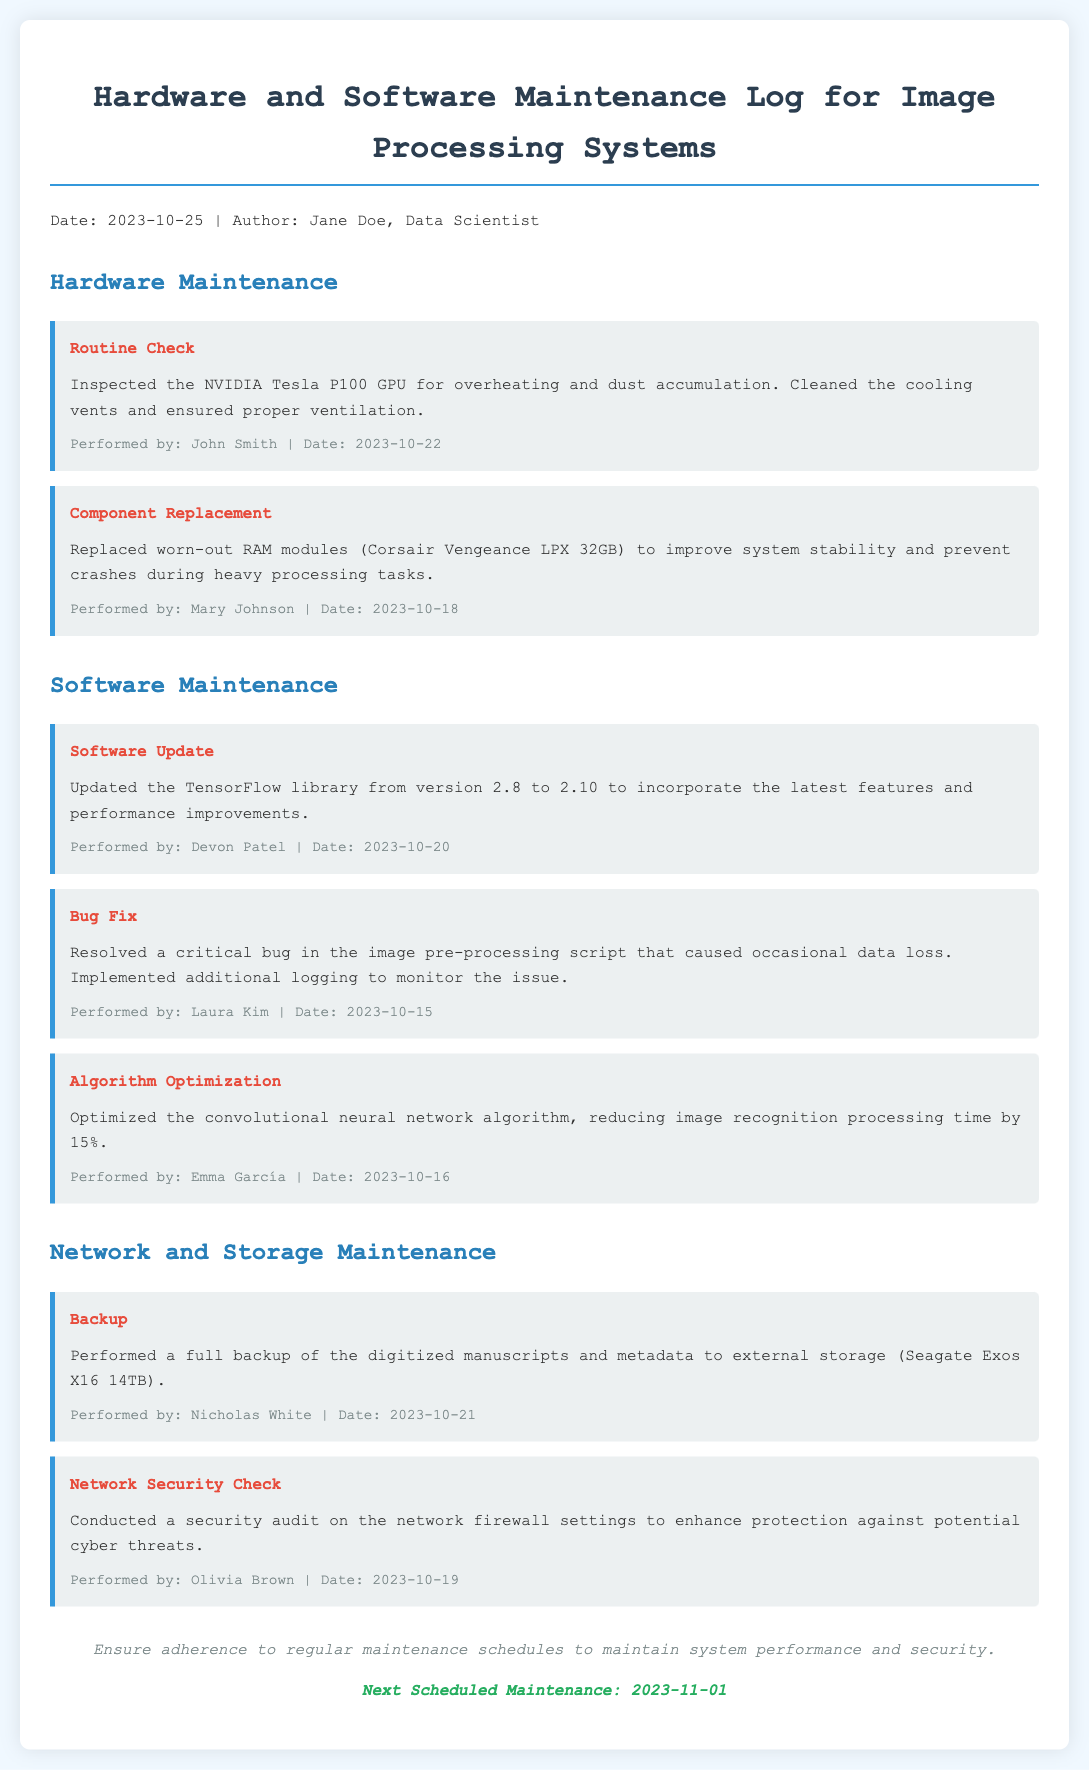what was the date of the routine check? The routine check was performed on 2023-10-22 as noted in the log entry.
Answer: 2023-10-22 who performed the component replacement? The component replacement was performed by Mary Johnson, as indicated in the entry.
Answer: Mary Johnson what software was updated? The log states that the TensorFlow library was updated, which is highlighted under software maintenance.
Answer: TensorFlow how much RAM was replaced? The entry specifies that 32GB RAM modules were replaced to improve system stability.
Answer: 32GB what was the outcome of the algorithm optimization? The optimization reduced image recognition processing time by 15%, as detailed in the software maintenance section.
Answer: 15% when is the next scheduled maintenance? The document mentions the next scheduled maintenance is on 2023-11-01.
Answer: 2023-11-01 what type of maintenance involved a network security check? The network security check falls under the category of network and storage maintenance, as per the document structure.
Answer: Network and storage maintenance what issue was resolved in the bug fix entry? The bug fix entry indicates a critical bug in the image pre-processing script was resolved, leading to monitoring improvements.
Answer: Critical bug in the image pre-processing script 